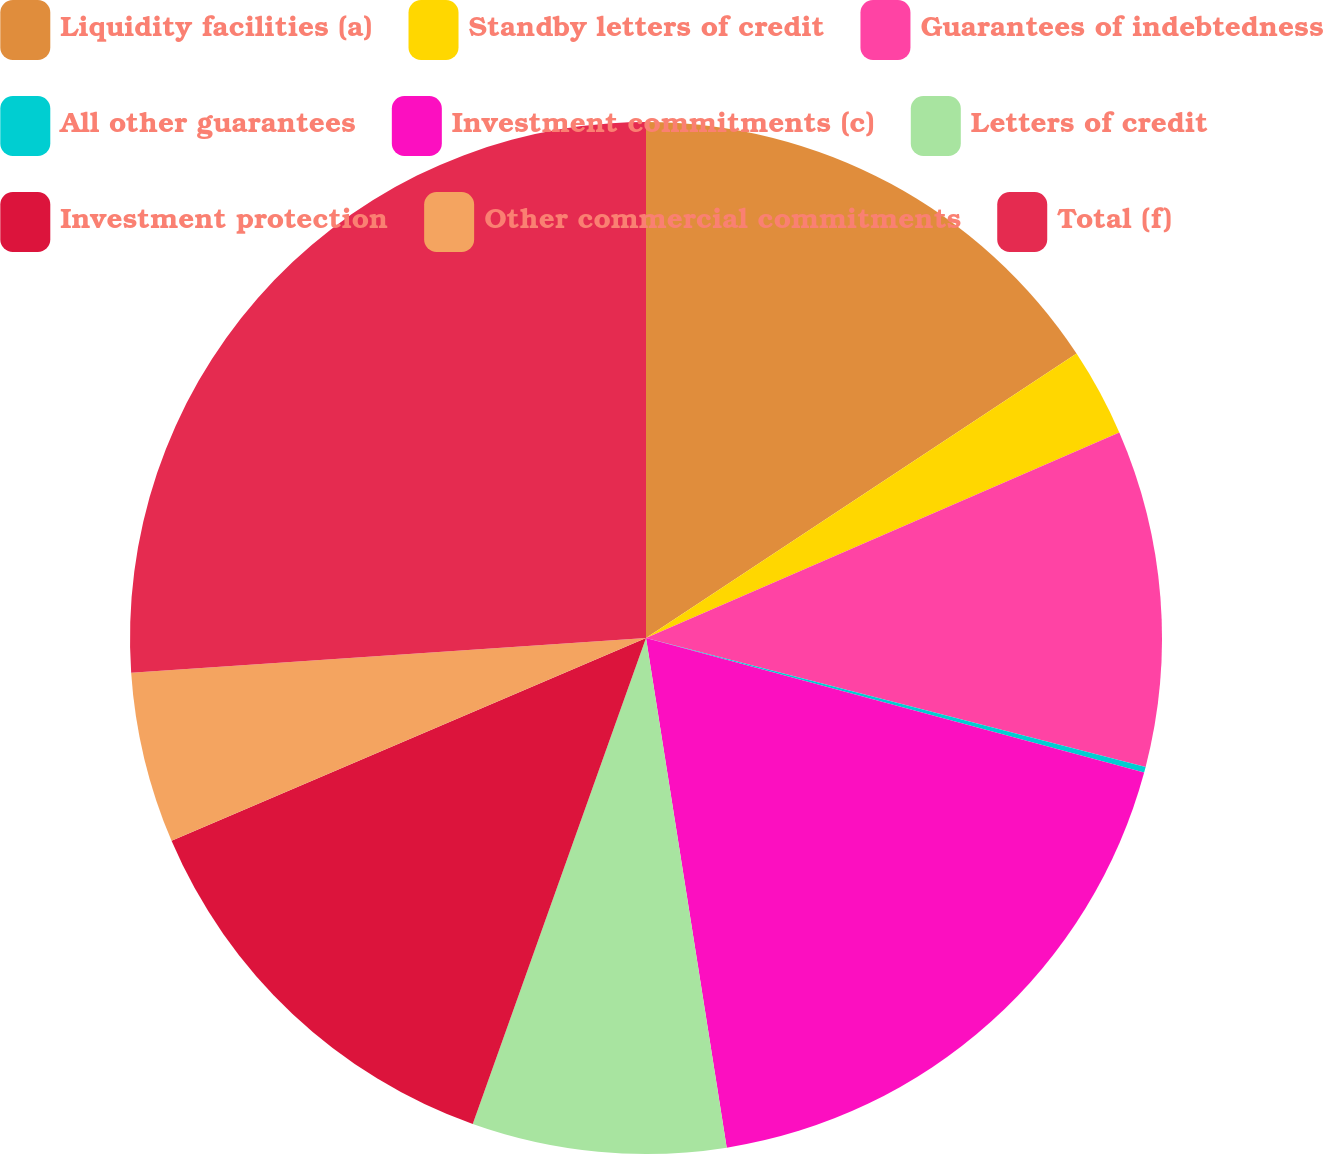Convert chart. <chart><loc_0><loc_0><loc_500><loc_500><pie_chart><fcel>Liquidity facilities (a)<fcel>Standby letters of credit<fcel>Guarantees of indebtedness<fcel>All other guarantees<fcel>Investment commitments (c)<fcel>Letters of credit<fcel>Investment protection<fcel>Other commercial commitments<fcel>Total (f)<nl><fcel>15.71%<fcel>2.77%<fcel>10.54%<fcel>0.18%<fcel>18.3%<fcel>7.95%<fcel>13.12%<fcel>5.36%<fcel>26.07%<nl></chart> 